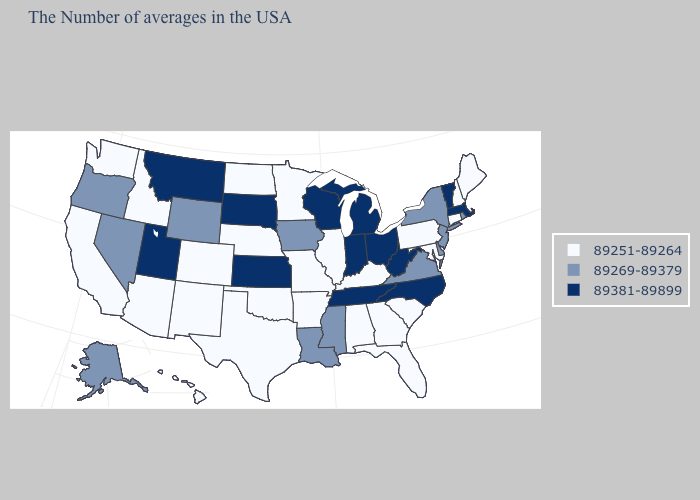What is the value of Kansas?
Keep it brief. 89381-89899. Among the states that border North Carolina , which have the lowest value?
Concise answer only. South Carolina, Georgia. What is the highest value in the USA?
Concise answer only. 89381-89899. Does Kansas have the highest value in the USA?
Be succinct. Yes. Does Kansas have the same value as West Virginia?
Short answer required. Yes. Among the states that border Oregon , which have the highest value?
Be succinct. Nevada. Among the states that border Connecticut , does Massachusetts have the lowest value?
Quick response, please. No. Name the states that have a value in the range 89269-89379?
Answer briefly. Rhode Island, New York, New Jersey, Delaware, Virginia, Mississippi, Louisiana, Iowa, Wyoming, Nevada, Oregon, Alaska. What is the highest value in states that border Arizona?
Concise answer only. 89381-89899. Does Kansas have a higher value than Vermont?
Give a very brief answer. No. Name the states that have a value in the range 89381-89899?
Concise answer only. Massachusetts, Vermont, North Carolina, West Virginia, Ohio, Michigan, Indiana, Tennessee, Wisconsin, Kansas, South Dakota, Utah, Montana. What is the lowest value in the USA?
Quick response, please. 89251-89264. What is the lowest value in states that border North Dakota?
Keep it brief. 89251-89264. What is the lowest value in the USA?
Short answer required. 89251-89264. 